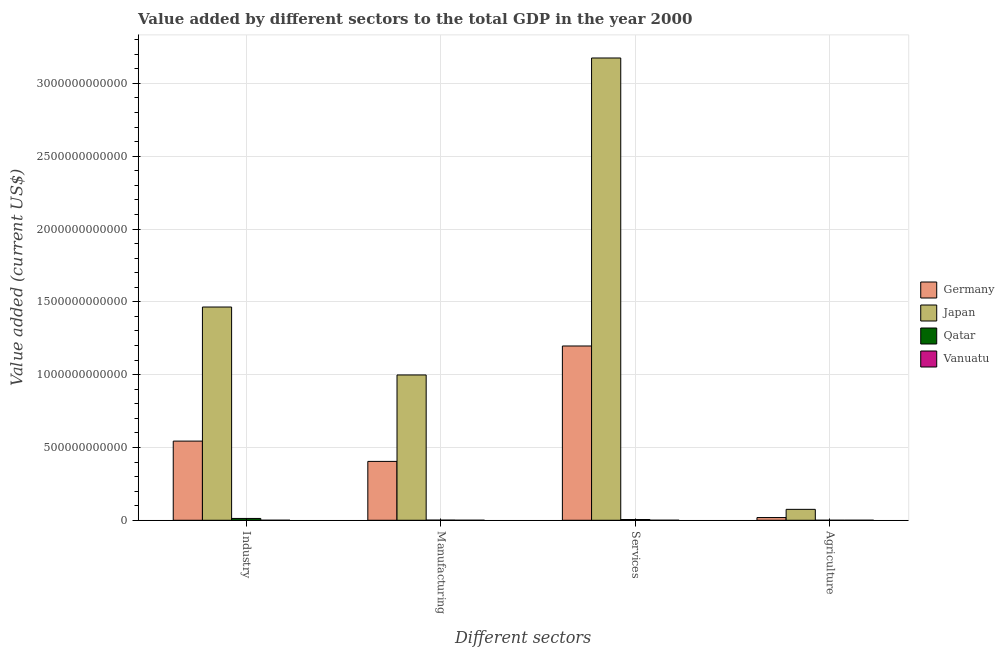How many bars are there on the 2nd tick from the left?
Provide a succinct answer. 4. How many bars are there on the 1st tick from the right?
Your answer should be very brief. 4. What is the label of the 4th group of bars from the left?
Provide a short and direct response. Agriculture. What is the value added by industrial sector in Germany?
Make the answer very short. 5.44e+11. Across all countries, what is the maximum value added by agricultural sector?
Offer a very short reply. 7.49e+1. Across all countries, what is the minimum value added by services sector?
Give a very brief answer. 1.46e+08. In which country was the value added by services sector minimum?
Ensure brevity in your answer.  Vanuatu. What is the total value added by industrial sector in the graph?
Keep it short and to the point. 2.02e+12. What is the difference between the value added by services sector in Japan and that in Germany?
Give a very brief answer. 1.98e+12. What is the difference between the value added by agricultural sector in Qatar and the value added by industrial sector in Germany?
Give a very brief answer. -5.44e+11. What is the average value added by agricultural sector per country?
Make the answer very short. 2.34e+1. What is the difference between the value added by manufacturing sector and value added by agricultural sector in Vanuatu?
Offer a very short reply. -5.02e+07. What is the ratio of the value added by agricultural sector in Qatar to that in Germany?
Provide a succinct answer. 0. Is the value added by industrial sector in Japan less than that in Qatar?
Offer a very short reply. No. Is the difference between the value added by industrial sector in Germany and Vanuatu greater than the difference between the value added by agricultural sector in Germany and Vanuatu?
Ensure brevity in your answer.  Yes. What is the difference between the highest and the second highest value added by industrial sector?
Your answer should be compact. 9.21e+11. What is the difference between the highest and the lowest value added by services sector?
Provide a short and direct response. 3.17e+12. What does the 3rd bar from the left in Agriculture represents?
Offer a terse response. Qatar. What does the 2nd bar from the right in Agriculture represents?
Offer a terse response. Qatar. Is it the case that in every country, the sum of the value added by industrial sector and value added by manufacturing sector is greater than the value added by services sector?
Your response must be concise. No. How many countries are there in the graph?
Provide a succinct answer. 4. What is the difference between two consecutive major ticks on the Y-axis?
Keep it short and to the point. 5.00e+11. Does the graph contain grids?
Your answer should be compact. Yes. Where does the legend appear in the graph?
Offer a terse response. Center right. How many legend labels are there?
Offer a terse response. 4. How are the legend labels stacked?
Provide a short and direct response. Vertical. What is the title of the graph?
Ensure brevity in your answer.  Value added by different sectors to the total GDP in the year 2000. Does "Mauritania" appear as one of the legend labels in the graph?
Your answer should be compact. No. What is the label or title of the X-axis?
Provide a short and direct response. Different sectors. What is the label or title of the Y-axis?
Your answer should be very brief. Value added (current US$). What is the Value added (current US$) in Germany in Industry?
Ensure brevity in your answer.  5.44e+11. What is the Value added (current US$) of Japan in Industry?
Your answer should be very brief. 1.46e+12. What is the Value added (current US$) of Qatar in Industry?
Make the answer very short. 1.26e+1. What is the Value added (current US$) of Vanuatu in Industry?
Provide a succinct answer. 3.05e+07. What is the Value added (current US$) of Germany in Manufacturing?
Provide a short and direct response. 4.04e+11. What is the Value added (current US$) of Japan in Manufacturing?
Your answer should be very brief. 9.98e+11. What is the Value added (current US$) of Qatar in Manufacturing?
Offer a very short reply. 9.66e+08. What is the Value added (current US$) of Vanuatu in Manufacturing?
Keep it short and to the point. 1.23e+07. What is the Value added (current US$) of Germany in Services?
Keep it short and to the point. 1.20e+12. What is the Value added (current US$) of Japan in Services?
Offer a very short reply. 3.17e+12. What is the Value added (current US$) in Qatar in Services?
Provide a short and direct response. 5.14e+09. What is the Value added (current US$) in Vanuatu in Services?
Offer a very short reply. 1.46e+08. What is the Value added (current US$) of Germany in Agriculture?
Make the answer very short. 1.86e+1. What is the Value added (current US$) of Japan in Agriculture?
Offer a terse response. 7.49e+1. What is the Value added (current US$) of Qatar in Agriculture?
Provide a succinct answer. 6.62e+07. What is the Value added (current US$) in Vanuatu in Agriculture?
Provide a short and direct response. 6.25e+07. Across all Different sectors, what is the maximum Value added (current US$) of Germany?
Provide a succinct answer. 1.20e+12. Across all Different sectors, what is the maximum Value added (current US$) of Japan?
Offer a terse response. 3.17e+12. Across all Different sectors, what is the maximum Value added (current US$) of Qatar?
Provide a short and direct response. 1.26e+1. Across all Different sectors, what is the maximum Value added (current US$) of Vanuatu?
Offer a very short reply. 1.46e+08. Across all Different sectors, what is the minimum Value added (current US$) of Germany?
Your response must be concise. 1.86e+1. Across all Different sectors, what is the minimum Value added (current US$) of Japan?
Offer a very short reply. 7.49e+1. Across all Different sectors, what is the minimum Value added (current US$) of Qatar?
Keep it short and to the point. 6.62e+07. Across all Different sectors, what is the minimum Value added (current US$) of Vanuatu?
Give a very brief answer. 1.23e+07. What is the total Value added (current US$) in Germany in the graph?
Provide a short and direct response. 2.16e+12. What is the total Value added (current US$) in Japan in the graph?
Offer a very short reply. 5.71e+12. What is the total Value added (current US$) of Qatar in the graph?
Keep it short and to the point. 1.87e+1. What is the total Value added (current US$) of Vanuatu in the graph?
Make the answer very short. 2.51e+08. What is the difference between the Value added (current US$) in Germany in Industry and that in Manufacturing?
Make the answer very short. 1.39e+11. What is the difference between the Value added (current US$) in Japan in Industry and that in Manufacturing?
Provide a short and direct response. 4.66e+11. What is the difference between the Value added (current US$) of Qatar in Industry and that in Manufacturing?
Your answer should be very brief. 1.16e+1. What is the difference between the Value added (current US$) in Vanuatu in Industry and that in Manufacturing?
Your answer should be very brief. 1.83e+07. What is the difference between the Value added (current US$) in Germany in Industry and that in Services?
Make the answer very short. -6.53e+11. What is the difference between the Value added (current US$) in Japan in Industry and that in Services?
Provide a short and direct response. -1.71e+12. What is the difference between the Value added (current US$) of Qatar in Industry and that in Services?
Offer a very short reply. 7.41e+09. What is the difference between the Value added (current US$) of Vanuatu in Industry and that in Services?
Ensure brevity in your answer.  -1.15e+08. What is the difference between the Value added (current US$) in Germany in Industry and that in Agriculture?
Give a very brief answer. 5.25e+11. What is the difference between the Value added (current US$) in Japan in Industry and that in Agriculture?
Your response must be concise. 1.39e+12. What is the difference between the Value added (current US$) in Qatar in Industry and that in Agriculture?
Your response must be concise. 1.25e+1. What is the difference between the Value added (current US$) in Vanuatu in Industry and that in Agriculture?
Your response must be concise. -3.19e+07. What is the difference between the Value added (current US$) in Germany in Manufacturing and that in Services?
Provide a succinct answer. -7.93e+11. What is the difference between the Value added (current US$) of Japan in Manufacturing and that in Services?
Offer a very short reply. -2.18e+12. What is the difference between the Value added (current US$) in Qatar in Manufacturing and that in Services?
Offer a terse response. -4.18e+09. What is the difference between the Value added (current US$) in Vanuatu in Manufacturing and that in Services?
Provide a short and direct response. -1.33e+08. What is the difference between the Value added (current US$) in Germany in Manufacturing and that in Agriculture?
Offer a terse response. 3.86e+11. What is the difference between the Value added (current US$) in Japan in Manufacturing and that in Agriculture?
Provide a short and direct response. 9.23e+11. What is the difference between the Value added (current US$) in Qatar in Manufacturing and that in Agriculture?
Your answer should be compact. 8.99e+08. What is the difference between the Value added (current US$) of Vanuatu in Manufacturing and that in Agriculture?
Give a very brief answer. -5.02e+07. What is the difference between the Value added (current US$) of Germany in Services and that in Agriculture?
Make the answer very short. 1.18e+12. What is the difference between the Value added (current US$) of Japan in Services and that in Agriculture?
Give a very brief answer. 3.10e+12. What is the difference between the Value added (current US$) of Qatar in Services and that in Agriculture?
Provide a short and direct response. 5.08e+09. What is the difference between the Value added (current US$) of Vanuatu in Services and that in Agriculture?
Offer a very short reply. 8.31e+07. What is the difference between the Value added (current US$) in Germany in Industry and the Value added (current US$) in Japan in Manufacturing?
Keep it short and to the point. -4.54e+11. What is the difference between the Value added (current US$) of Germany in Industry and the Value added (current US$) of Qatar in Manufacturing?
Provide a succinct answer. 5.43e+11. What is the difference between the Value added (current US$) of Germany in Industry and the Value added (current US$) of Vanuatu in Manufacturing?
Your answer should be very brief. 5.44e+11. What is the difference between the Value added (current US$) of Japan in Industry and the Value added (current US$) of Qatar in Manufacturing?
Your response must be concise. 1.46e+12. What is the difference between the Value added (current US$) in Japan in Industry and the Value added (current US$) in Vanuatu in Manufacturing?
Give a very brief answer. 1.46e+12. What is the difference between the Value added (current US$) in Qatar in Industry and the Value added (current US$) in Vanuatu in Manufacturing?
Offer a very short reply. 1.25e+1. What is the difference between the Value added (current US$) of Germany in Industry and the Value added (current US$) of Japan in Services?
Your answer should be compact. -2.63e+12. What is the difference between the Value added (current US$) in Germany in Industry and the Value added (current US$) in Qatar in Services?
Your response must be concise. 5.39e+11. What is the difference between the Value added (current US$) in Germany in Industry and the Value added (current US$) in Vanuatu in Services?
Offer a terse response. 5.44e+11. What is the difference between the Value added (current US$) in Japan in Industry and the Value added (current US$) in Qatar in Services?
Offer a terse response. 1.46e+12. What is the difference between the Value added (current US$) of Japan in Industry and the Value added (current US$) of Vanuatu in Services?
Your response must be concise. 1.46e+12. What is the difference between the Value added (current US$) in Qatar in Industry and the Value added (current US$) in Vanuatu in Services?
Provide a succinct answer. 1.24e+1. What is the difference between the Value added (current US$) in Germany in Industry and the Value added (current US$) in Japan in Agriculture?
Make the answer very short. 4.69e+11. What is the difference between the Value added (current US$) in Germany in Industry and the Value added (current US$) in Qatar in Agriculture?
Provide a succinct answer. 5.44e+11. What is the difference between the Value added (current US$) in Germany in Industry and the Value added (current US$) in Vanuatu in Agriculture?
Your response must be concise. 5.44e+11. What is the difference between the Value added (current US$) of Japan in Industry and the Value added (current US$) of Qatar in Agriculture?
Offer a terse response. 1.46e+12. What is the difference between the Value added (current US$) in Japan in Industry and the Value added (current US$) in Vanuatu in Agriculture?
Provide a short and direct response. 1.46e+12. What is the difference between the Value added (current US$) of Qatar in Industry and the Value added (current US$) of Vanuatu in Agriculture?
Give a very brief answer. 1.25e+1. What is the difference between the Value added (current US$) in Germany in Manufacturing and the Value added (current US$) in Japan in Services?
Keep it short and to the point. -2.77e+12. What is the difference between the Value added (current US$) of Germany in Manufacturing and the Value added (current US$) of Qatar in Services?
Give a very brief answer. 3.99e+11. What is the difference between the Value added (current US$) in Germany in Manufacturing and the Value added (current US$) in Vanuatu in Services?
Ensure brevity in your answer.  4.04e+11. What is the difference between the Value added (current US$) in Japan in Manufacturing and the Value added (current US$) in Qatar in Services?
Keep it short and to the point. 9.93e+11. What is the difference between the Value added (current US$) of Japan in Manufacturing and the Value added (current US$) of Vanuatu in Services?
Ensure brevity in your answer.  9.98e+11. What is the difference between the Value added (current US$) of Qatar in Manufacturing and the Value added (current US$) of Vanuatu in Services?
Provide a succinct answer. 8.20e+08. What is the difference between the Value added (current US$) in Germany in Manufacturing and the Value added (current US$) in Japan in Agriculture?
Your response must be concise. 3.29e+11. What is the difference between the Value added (current US$) of Germany in Manufacturing and the Value added (current US$) of Qatar in Agriculture?
Ensure brevity in your answer.  4.04e+11. What is the difference between the Value added (current US$) of Germany in Manufacturing and the Value added (current US$) of Vanuatu in Agriculture?
Your answer should be compact. 4.04e+11. What is the difference between the Value added (current US$) of Japan in Manufacturing and the Value added (current US$) of Qatar in Agriculture?
Keep it short and to the point. 9.98e+11. What is the difference between the Value added (current US$) of Japan in Manufacturing and the Value added (current US$) of Vanuatu in Agriculture?
Your answer should be very brief. 9.98e+11. What is the difference between the Value added (current US$) in Qatar in Manufacturing and the Value added (current US$) in Vanuatu in Agriculture?
Ensure brevity in your answer.  9.03e+08. What is the difference between the Value added (current US$) of Germany in Services and the Value added (current US$) of Japan in Agriculture?
Your answer should be compact. 1.12e+12. What is the difference between the Value added (current US$) in Germany in Services and the Value added (current US$) in Qatar in Agriculture?
Keep it short and to the point. 1.20e+12. What is the difference between the Value added (current US$) of Germany in Services and the Value added (current US$) of Vanuatu in Agriculture?
Make the answer very short. 1.20e+12. What is the difference between the Value added (current US$) of Japan in Services and the Value added (current US$) of Qatar in Agriculture?
Offer a terse response. 3.17e+12. What is the difference between the Value added (current US$) in Japan in Services and the Value added (current US$) in Vanuatu in Agriculture?
Make the answer very short. 3.17e+12. What is the difference between the Value added (current US$) of Qatar in Services and the Value added (current US$) of Vanuatu in Agriculture?
Provide a short and direct response. 5.08e+09. What is the average Value added (current US$) in Germany per Different sectors?
Offer a very short reply. 5.41e+11. What is the average Value added (current US$) of Japan per Different sectors?
Your response must be concise. 1.43e+12. What is the average Value added (current US$) of Qatar per Different sectors?
Make the answer very short. 4.68e+09. What is the average Value added (current US$) of Vanuatu per Different sectors?
Your answer should be compact. 6.27e+07. What is the difference between the Value added (current US$) of Germany and Value added (current US$) of Japan in Industry?
Your answer should be very brief. -9.21e+11. What is the difference between the Value added (current US$) of Germany and Value added (current US$) of Qatar in Industry?
Your answer should be compact. 5.31e+11. What is the difference between the Value added (current US$) of Germany and Value added (current US$) of Vanuatu in Industry?
Offer a terse response. 5.44e+11. What is the difference between the Value added (current US$) of Japan and Value added (current US$) of Qatar in Industry?
Make the answer very short. 1.45e+12. What is the difference between the Value added (current US$) in Japan and Value added (current US$) in Vanuatu in Industry?
Offer a very short reply. 1.46e+12. What is the difference between the Value added (current US$) of Qatar and Value added (current US$) of Vanuatu in Industry?
Offer a very short reply. 1.25e+1. What is the difference between the Value added (current US$) of Germany and Value added (current US$) of Japan in Manufacturing?
Offer a very short reply. -5.94e+11. What is the difference between the Value added (current US$) in Germany and Value added (current US$) in Qatar in Manufacturing?
Give a very brief answer. 4.03e+11. What is the difference between the Value added (current US$) of Germany and Value added (current US$) of Vanuatu in Manufacturing?
Your response must be concise. 4.04e+11. What is the difference between the Value added (current US$) in Japan and Value added (current US$) in Qatar in Manufacturing?
Make the answer very short. 9.97e+11. What is the difference between the Value added (current US$) of Japan and Value added (current US$) of Vanuatu in Manufacturing?
Provide a short and direct response. 9.98e+11. What is the difference between the Value added (current US$) in Qatar and Value added (current US$) in Vanuatu in Manufacturing?
Offer a terse response. 9.53e+08. What is the difference between the Value added (current US$) of Germany and Value added (current US$) of Japan in Services?
Your answer should be compact. -1.98e+12. What is the difference between the Value added (current US$) of Germany and Value added (current US$) of Qatar in Services?
Your answer should be very brief. 1.19e+12. What is the difference between the Value added (current US$) in Germany and Value added (current US$) in Vanuatu in Services?
Ensure brevity in your answer.  1.20e+12. What is the difference between the Value added (current US$) in Japan and Value added (current US$) in Qatar in Services?
Keep it short and to the point. 3.17e+12. What is the difference between the Value added (current US$) in Japan and Value added (current US$) in Vanuatu in Services?
Give a very brief answer. 3.17e+12. What is the difference between the Value added (current US$) of Qatar and Value added (current US$) of Vanuatu in Services?
Offer a terse response. 5.00e+09. What is the difference between the Value added (current US$) in Germany and Value added (current US$) in Japan in Agriculture?
Your response must be concise. -5.64e+1. What is the difference between the Value added (current US$) of Germany and Value added (current US$) of Qatar in Agriculture?
Provide a short and direct response. 1.85e+1. What is the difference between the Value added (current US$) of Germany and Value added (current US$) of Vanuatu in Agriculture?
Offer a terse response. 1.85e+1. What is the difference between the Value added (current US$) in Japan and Value added (current US$) in Qatar in Agriculture?
Your response must be concise. 7.49e+1. What is the difference between the Value added (current US$) in Japan and Value added (current US$) in Vanuatu in Agriculture?
Provide a succinct answer. 7.49e+1. What is the difference between the Value added (current US$) of Qatar and Value added (current US$) of Vanuatu in Agriculture?
Make the answer very short. 3.74e+06. What is the ratio of the Value added (current US$) in Germany in Industry to that in Manufacturing?
Your answer should be very brief. 1.34. What is the ratio of the Value added (current US$) of Japan in Industry to that in Manufacturing?
Your answer should be compact. 1.47. What is the ratio of the Value added (current US$) of Qatar in Industry to that in Manufacturing?
Keep it short and to the point. 13. What is the ratio of the Value added (current US$) of Vanuatu in Industry to that in Manufacturing?
Offer a terse response. 2.49. What is the ratio of the Value added (current US$) in Germany in Industry to that in Services?
Keep it short and to the point. 0.45. What is the ratio of the Value added (current US$) of Japan in Industry to that in Services?
Your response must be concise. 0.46. What is the ratio of the Value added (current US$) of Qatar in Industry to that in Services?
Give a very brief answer. 2.44. What is the ratio of the Value added (current US$) in Vanuatu in Industry to that in Services?
Your answer should be very brief. 0.21. What is the ratio of the Value added (current US$) in Germany in Industry to that in Agriculture?
Your answer should be compact. 29.25. What is the ratio of the Value added (current US$) in Japan in Industry to that in Agriculture?
Your answer should be very brief. 19.54. What is the ratio of the Value added (current US$) of Qatar in Industry to that in Agriculture?
Keep it short and to the point. 189.59. What is the ratio of the Value added (current US$) in Vanuatu in Industry to that in Agriculture?
Make the answer very short. 0.49. What is the ratio of the Value added (current US$) of Germany in Manufacturing to that in Services?
Offer a very short reply. 0.34. What is the ratio of the Value added (current US$) in Japan in Manufacturing to that in Services?
Offer a terse response. 0.31. What is the ratio of the Value added (current US$) in Qatar in Manufacturing to that in Services?
Provide a short and direct response. 0.19. What is the ratio of the Value added (current US$) of Vanuatu in Manufacturing to that in Services?
Ensure brevity in your answer.  0.08. What is the ratio of the Value added (current US$) in Germany in Manufacturing to that in Agriculture?
Your answer should be compact. 21.75. What is the ratio of the Value added (current US$) of Japan in Manufacturing to that in Agriculture?
Your answer should be compact. 13.31. What is the ratio of the Value added (current US$) of Qatar in Manufacturing to that in Agriculture?
Give a very brief answer. 14.59. What is the ratio of the Value added (current US$) in Vanuatu in Manufacturing to that in Agriculture?
Ensure brevity in your answer.  0.2. What is the ratio of the Value added (current US$) in Germany in Services to that in Agriculture?
Offer a very short reply. 64.39. What is the ratio of the Value added (current US$) in Japan in Services to that in Agriculture?
Your answer should be compact. 42.36. What is the ratio of the Value added (current US$) in Qatar in Services to that in Agriculture?
Provide a short and direct response. 77.66. What is the ratio of the Value added (current US$) of Vanuatu in Services to that in Agriculture?
Your response must be concise. 2.33. What is the difference between the highest and the second highest Value added (current US$) of Germany?
Offer a terse response. 6.53e+11. What is the difference between the highest and the second highest Value added (current US$) of Japan?
Your answer should be compact. 1.71e+12. What is the difference between the highest and the second highest Value added (current US$) of Qatar?
Ensure brevity in your answer.  7.41e+09. What is the difference between the highest and the second highest Value added (current US$) of Vanuatu?
Ensure brevity in your answer.  8.31e+07. What is the difference between the highest and the lowest Value added (current US$) in Germany?
Make the answer very short. 1.18e+12. What is the difference between the highest and the lowest Value added (current US$) of Japan?
Provide a succinct answer. 3.10e+12. What is the difference between the highest and the lowest Value added (current US$) of Qatar?
Make the answer very short. 1.25e+1. What is the difference between the highest and the lowest Value added (current US$) of Vanuatu?
Give a very brief answer. 1.33e+08. 